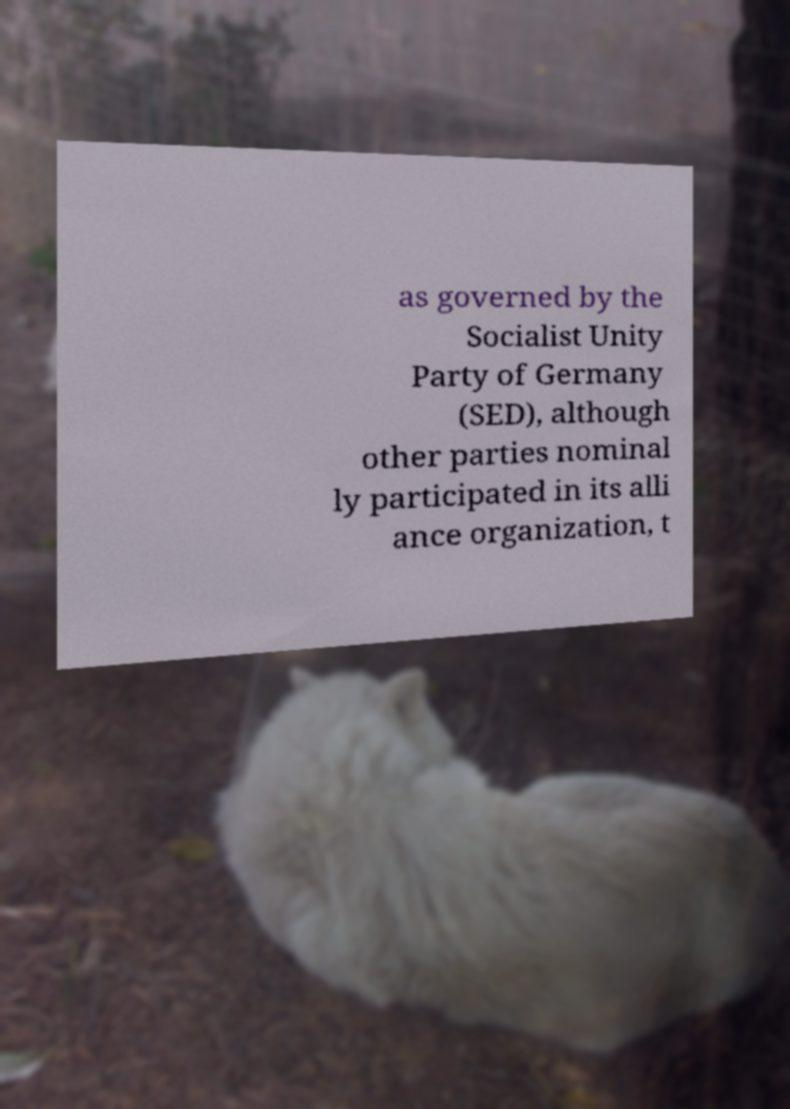There's text embedded in this image that I need extracted. Can you transcribe it verbatim? as governed by the Socialist Unity Party of Germany (SED), although other parties nominal ly participated in its alli ance organization, t 